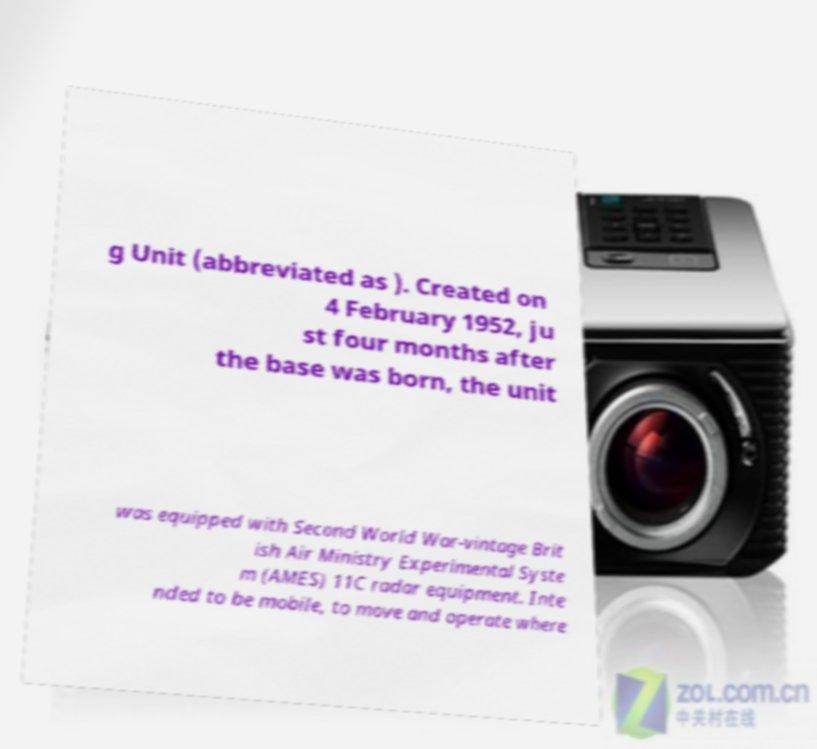I need the written content from this picture converted into text. Can you do that? g Unit (abbreviated as ). Created on 4 February 1952, ju st four months after the base was born, the unit was equipped with Second World War-vintage Brit ish Air Ministry Experimental Syste m (AMES) 11C radar equipment. Inte nded to be mobile, to move and operate where 